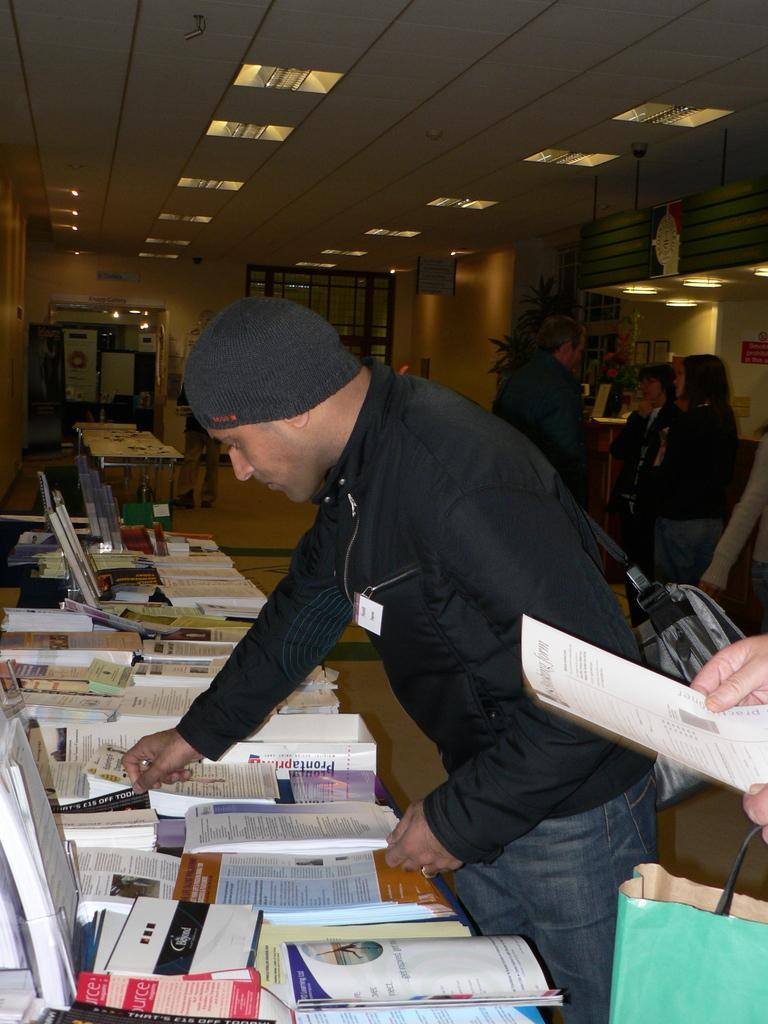Who or what is present in the image? There are people in the image. What can be seen illuminating the scene? There are lights in the image. What type of furniture is visible in the image? There are tables in the image. What electronic devices are on the tables? There are laptops on the tables. What other items can be seen on the tables? There are books and papers on the tables. What month is it in the image? The month cannot be determined from the image, as there is no information about the time of year. Is there a boy present in the image? The gender of the people in the image cannot be determined from the image, as there is no information about their gender. 